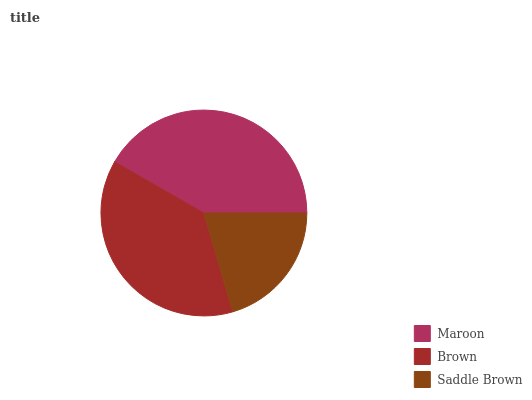Is Saddle Brown the minimum?
Answer yes or no. Yes. Is Maroon the maximum?
Answer yes or no. Yes. Is Brown the minimum?
Answer yes or no. No. Is Brown the maximum?
Answer yes or no. No. Is Maroon greater than Brown?
Answer yes or no. Yes. Is Brown less than Maroon?
Answer yes or no. Yes. Is Brown greater than Maroon?
Answer yes or no. No. Is Maroon less than Brown?
Answer yes or no. No. Is Brown the high median?
Answer yes or no. Yes. Is Brown the low median?
Answer yes or no. Yes. Is Saddle Brown the high median?
Answer yes or no. No. Is Saddle Brown the low median?
Answer yes or no. No. 